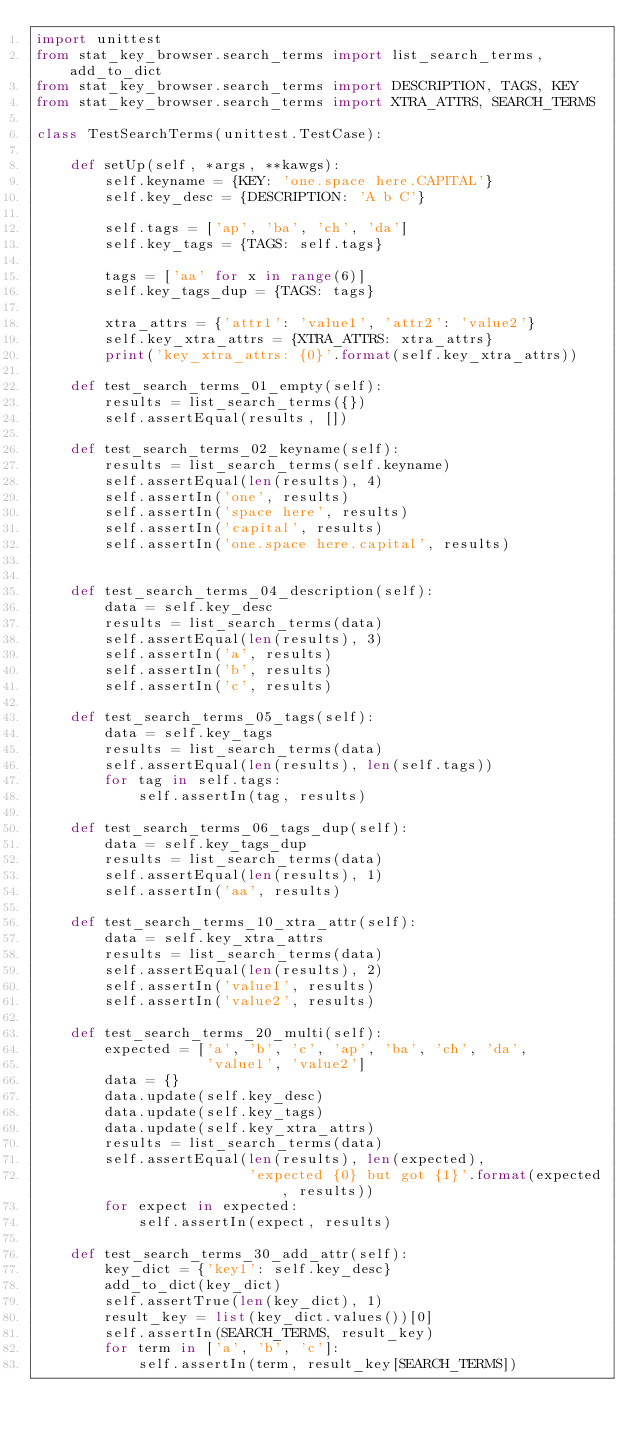Convert code to text. <code><loc_0><loc_0><loc_500><loc_500><_Python_>import unittest
from stat_key_browser.search_terms import list_search_terms, add_to_dict
from stat_key_browser.search_terms import DESCRIPTION, TAGS, KEY
from stat_key_browser.search_terms import XTRA_ATTRS, SEARCH_TERMS

class TestSearchTerms(unittest.TestCase):

    def setUp(self, *args, **kawgs):
        self.keyname = {KEY: 'one.space here.CAPITAL'}
        self.key_desc = {DESCRIPTION: 'A b C'}

        self.tags = ['ap', 'ba', 'ch', 'da']
        self.key_tags = {TAGS: self.tags}

        tags = ['aa' for x in range(6)]
        self.key_tags_dup = {TAGS: tags}

        xtra_attrs = {'attr1': 'value1', 'attr2': 'value2'}
        self.key_xtra_attrs = {XTRA_ATTRS: xtra_attrs}
        print('key_xtra_attrs: {0}'.format(self.key_xtra_attrs))

    def test_search_terms_01_empty(self):
        results = list_search_terms({})
        self.assertEqual(results, [])

    def test_search_terms_02_keyname(self):
        results = list_search_terms(self.keyname)
        self.assertEqual(len(results), 4)
        self.assertIn('one', results)
        self.assertIn('space here', results)
        self.assertIn('capital', results)
        self.assertIn('one.space here.capital', results)


    def test_search_terms_04_description(self):
        data = self.key_desc
        results = list_search_terms(data)
        self.assertEqual(len(results), 3)
        self.assertIn('a', results)
        self.assertIn('b', results)
        self.assertIn('c', results)

    def test_search_terms_05_tags(self):
        data = self.key_tags
        results = list_search_terms(data)
        self.assertEqual(len(results), len(self.tags))
        for tag in self.tags:
            self.assertIn(tag, results)

    def test_search_terms_06_tags_dup(self):
        data = self.key_tags_dup
        results = list_search_terms(data)
        self.assertEqual(len(results), 1)
        self.assertIn('aa', results)

    def test_search_terms_10_xtra_attr(self):
        data = self.key_xtra_attrs
        results = list_search_terms(data)
        self.assertEqual(len(results), 2)
        self.assertIn('value1', results)
        self.assertIn('value2', results)

    def test_search_terms_20_multi(self):
        expected = ['a', 'b', 'c', 'ap', 'ba', 'ch', 'da',
                    'value1', 'value2']
        data = {}
        data.update(self.key_desc)
        data.update(self.key_tags)
        data.update(self.key_xtra_attrs)
        results = list_search_terms(data)
        self.assertEqual(len(results), len(expected),
                         'expected {0} but got {1}'.format(expected, results))
        for expect in expected:
            self.assertIn(expect, results)

    def test_search_terms_30_add_attr(self):
        key_dict = {'key1': self.key_desc}
        add_to_dict(key_dict)
        self.assertTrue(len(key_dict), 1)
        result_key = list(key_dict.values())[0]
        self.assertIn(SEARCH_TERMS, result_key)
        for term in ['a', 'b', 'c']:
            self.assertIn(term, result_key[SEARCH_TERMS])
</code> 